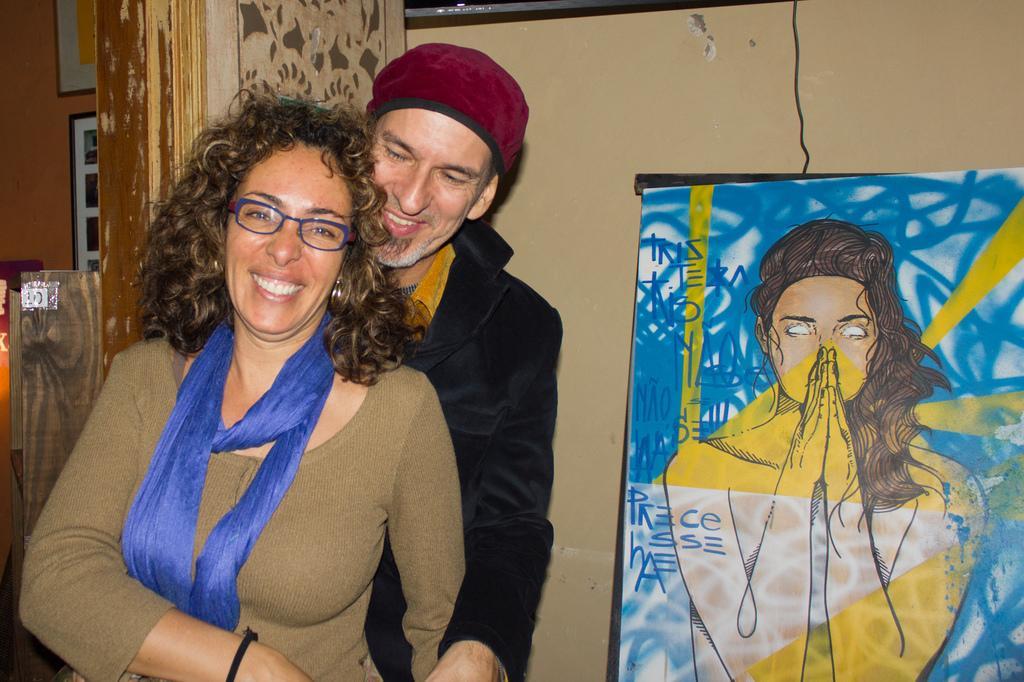Please provide a concise description of this image. In this picture there is a man and a woman on the left side of the image and there is a poster on the right side of the image and there is a pillar behind them, it seems to be there is a window in the background area of the image. 